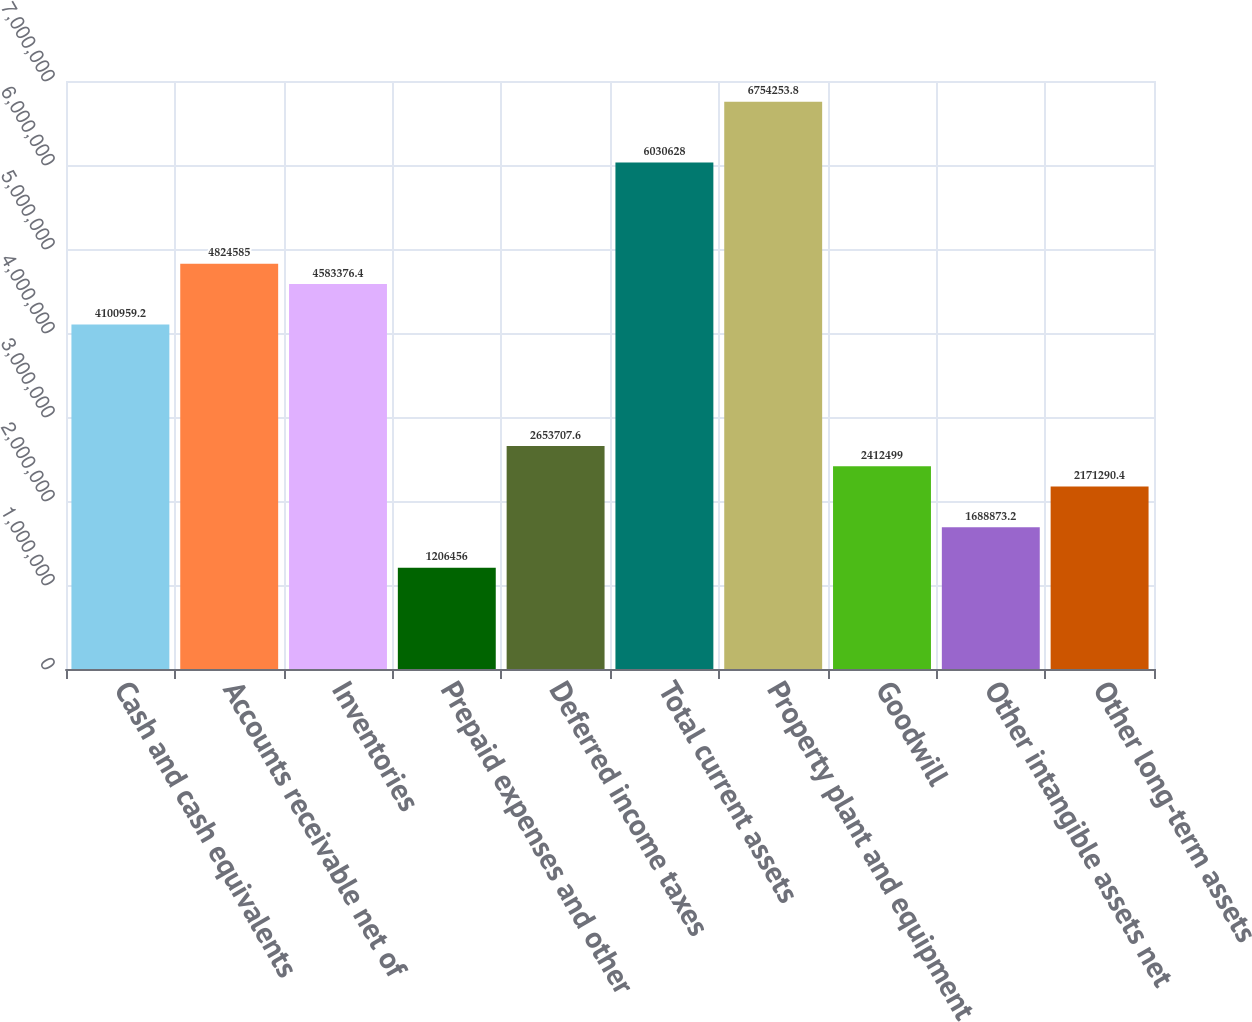<chart> <loc_0><loc_0><loc_500><loc_500><bar_chart><fcel>Cash and cash equivalents<fcel>Accounts receivable net of<fcel>Inventories<fcel>Prepaid expenses and other<fcel>Deferred income taxes<fcel>Total current assets<fcel>Property plant and equipment<fcel>Goodwill<fcel>Other intangible assets net<fcel>Other long-term assets<nl><fcel>4.10096e+06<fcel>4.82458e+06<fcel>4.58338e+06<fcel>1.20646e+06<fcel>2.65371e+06<fcel>6.03063e+06<fcel>6.75425e+06<fcel>2.4125e+06<fcel>1.68887e+06<fcel>2.17129e+06<nl></chart> 